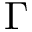Convert formula to latex. <formula><loc_0><loc_0><loc_500><loc_500>\Gamma</formula> 